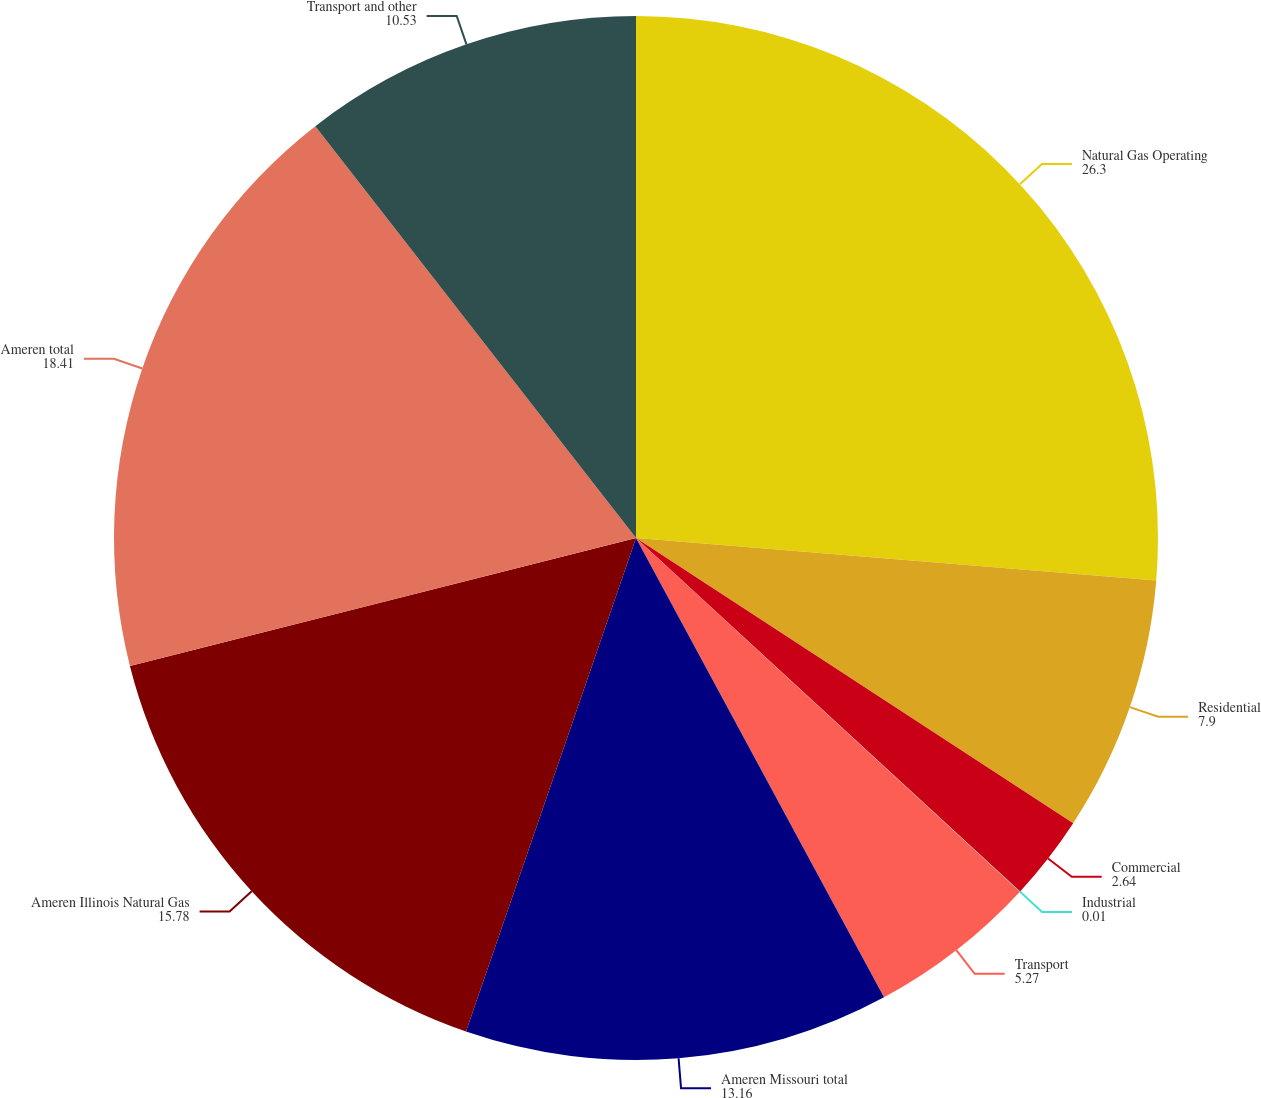Convert chart. <chart><loc_0><loc_0><loc_500><loc_500><pie_chart><fcel>Natural Gas Operating<fcel>Residential<fcel>Commercial<fcel>Industrial<fcel>Transport<fcel>Ameren Missouri total<fcel>Ameren Illinois Natural Gas<fcel>Ameren total<fcel>Transport and other<nl><fcel>26.3%<fcel>7.9%<fcel>2.64%<fcel>0.01%<fcel>5.27%<fcel>13.16%<fcel>15.78%<fcel>18.41%<fcel>10.53%<nl></chart> 